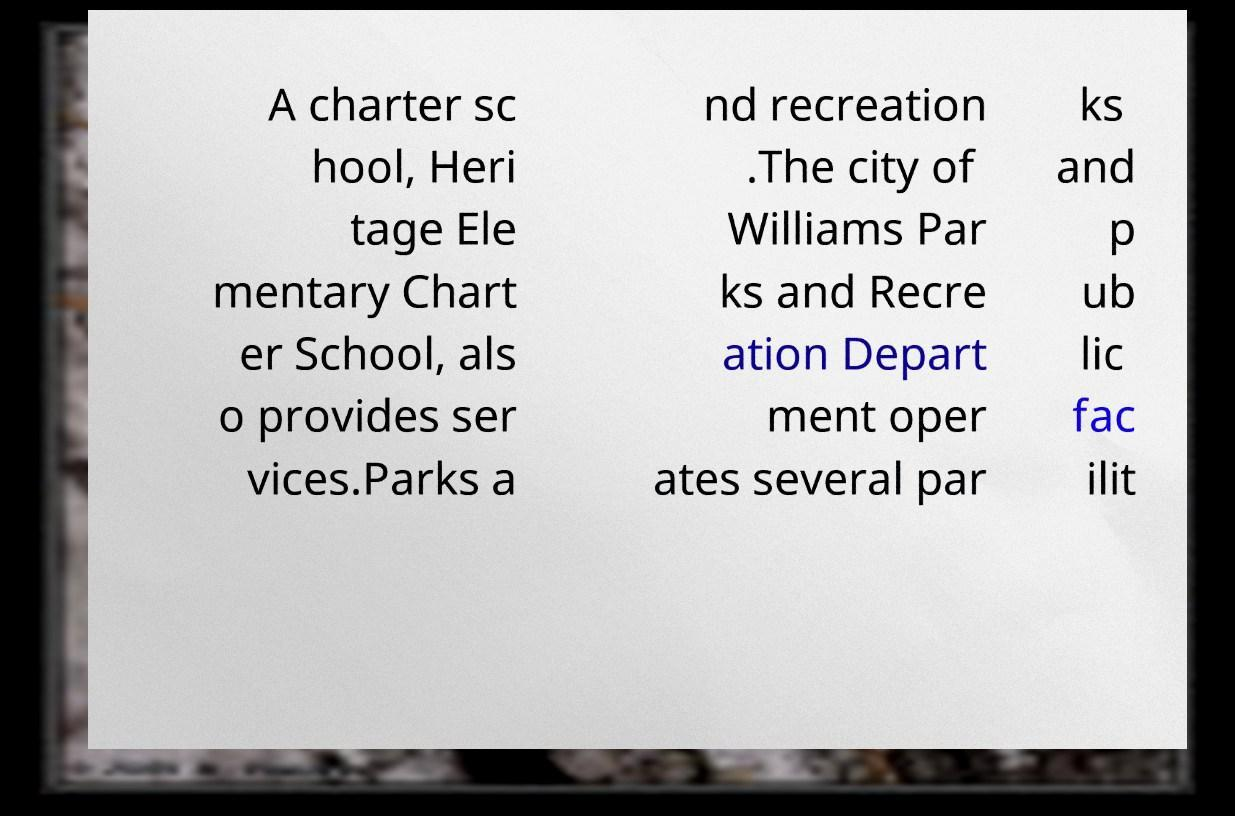There's text embedded in this image that I need extracted. Can you transcribe it verbatim? A charter sc hool, Heri tage Ele mentary Chart er School, als o provides ser vices.Parks a nd recreation .The city of Williams Par ks and Recre ation Depart ment oper ates several par ks and p ub lic fac ilit 